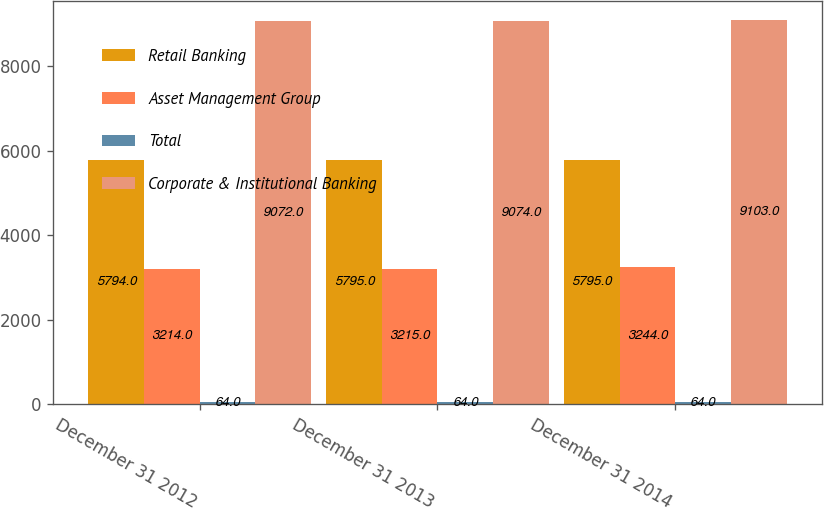Convert chart. <chart><loc_0><loc_0><loc_500><loc_500><stacked_bar_chart><ecel><fcel>December 31 2012<fcel>December 31 2013<fcel>December 31 2014<nl><fcel>Retail Banking<fcel>5794<fcel>5795<fcel>5795<nl><fcel>Asset Management Group<fcel>3214<fcel>3215<fcel>3244<nl><fcel>Total<fcel>64<fcel>64<fcel>64<nl><fcel>Corporate & Institutional Banking<fcel>9072<fcel>9074<fcel>9103<nl></chart> 